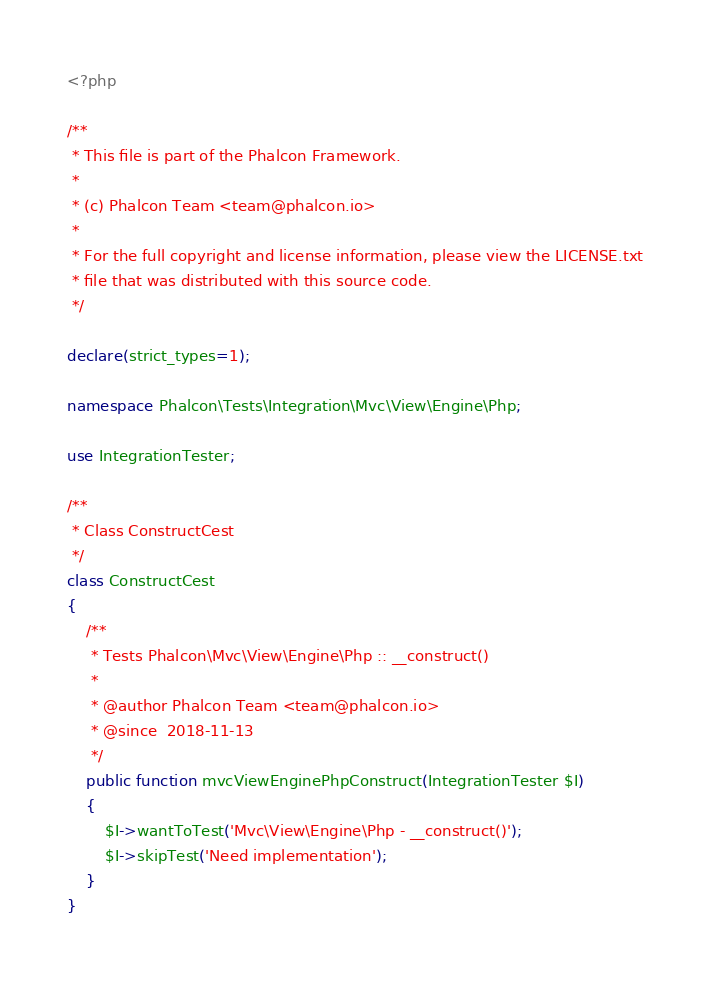<code> <loc_0><loc_0><loc_500><loc_500><_PHP_><?php

/**
 * This file is part of the Phalcon Framework.
 *
 * (c) Phalcon Team <team@phalcon.io>
 *
 * For the full copyright and license information, please view the LICENSE.txt
 * file that was distributed with this source code.
 */

declare(strict_types=1);

namespace Phalcon\Tests\Integration\Mvc\View\Engine\Php;

use IntegrationTester;

/**
 * Class ConstructCest
 */
class ConstructCest
{
    /**
     * Tests Phalcon\Mvc\View\Engine\Php :: __construct()
     *
     * @author Phalcon Team <team@phalcon.io>
     * @since  2018-11-13
     */
    public function mvcViewEnginePhpConstruct(IntegrationTester $I)
    {
        $I->wantToTest('Mvc\View\Engine\Php - __construct()');
        $I->skipTest('Need implementation');
    }
}
</code> 